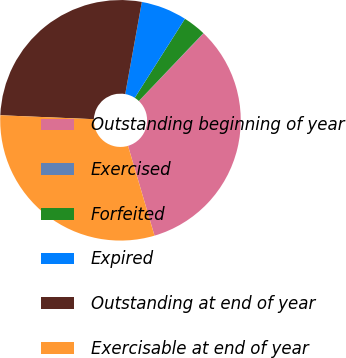Convert chart to OTSL. <chart><loc_0><loc_0><loc_500><loc_500><pie_chart><fcel>Outstanding beginning of year<fcel>Exercised<fcel>Forfeited<fcel>Expired<fcel>Outstanding at end of year<fcel>Exercisable at end of year<nl><fcel>33.29%<fcel>0.04%<fcel>3.1%<fcel>6.16%<fcel>27.17%<fcel>30.23%<nl></chart> 